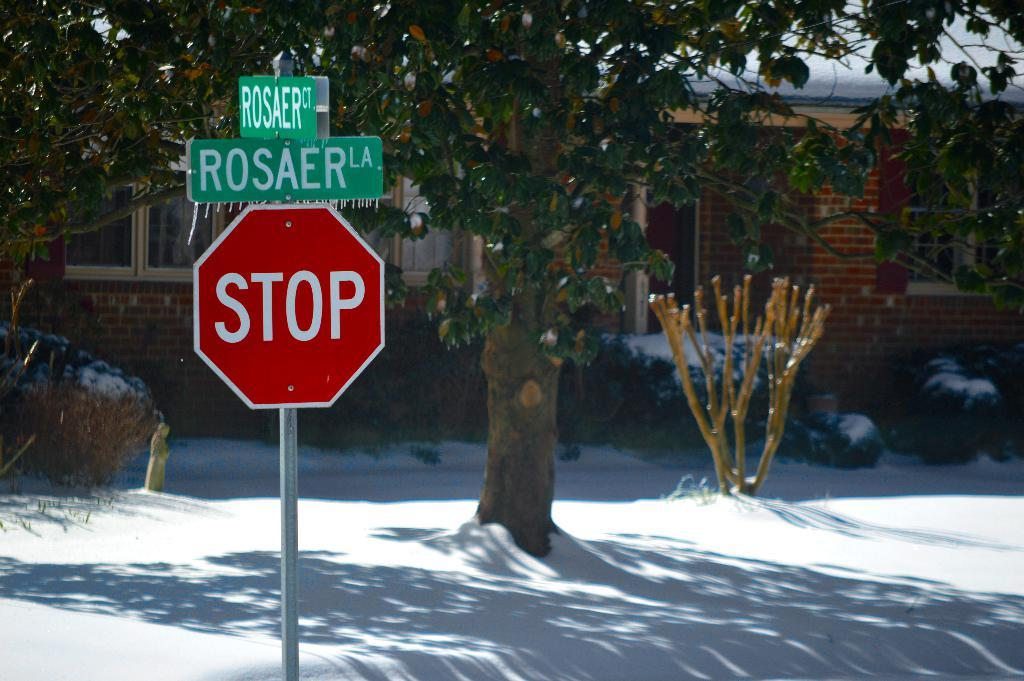<image>
Relay a brief, clear account of the picture shown. A stop sign sits at the corner of Rosaer Lane on a snowy day. 